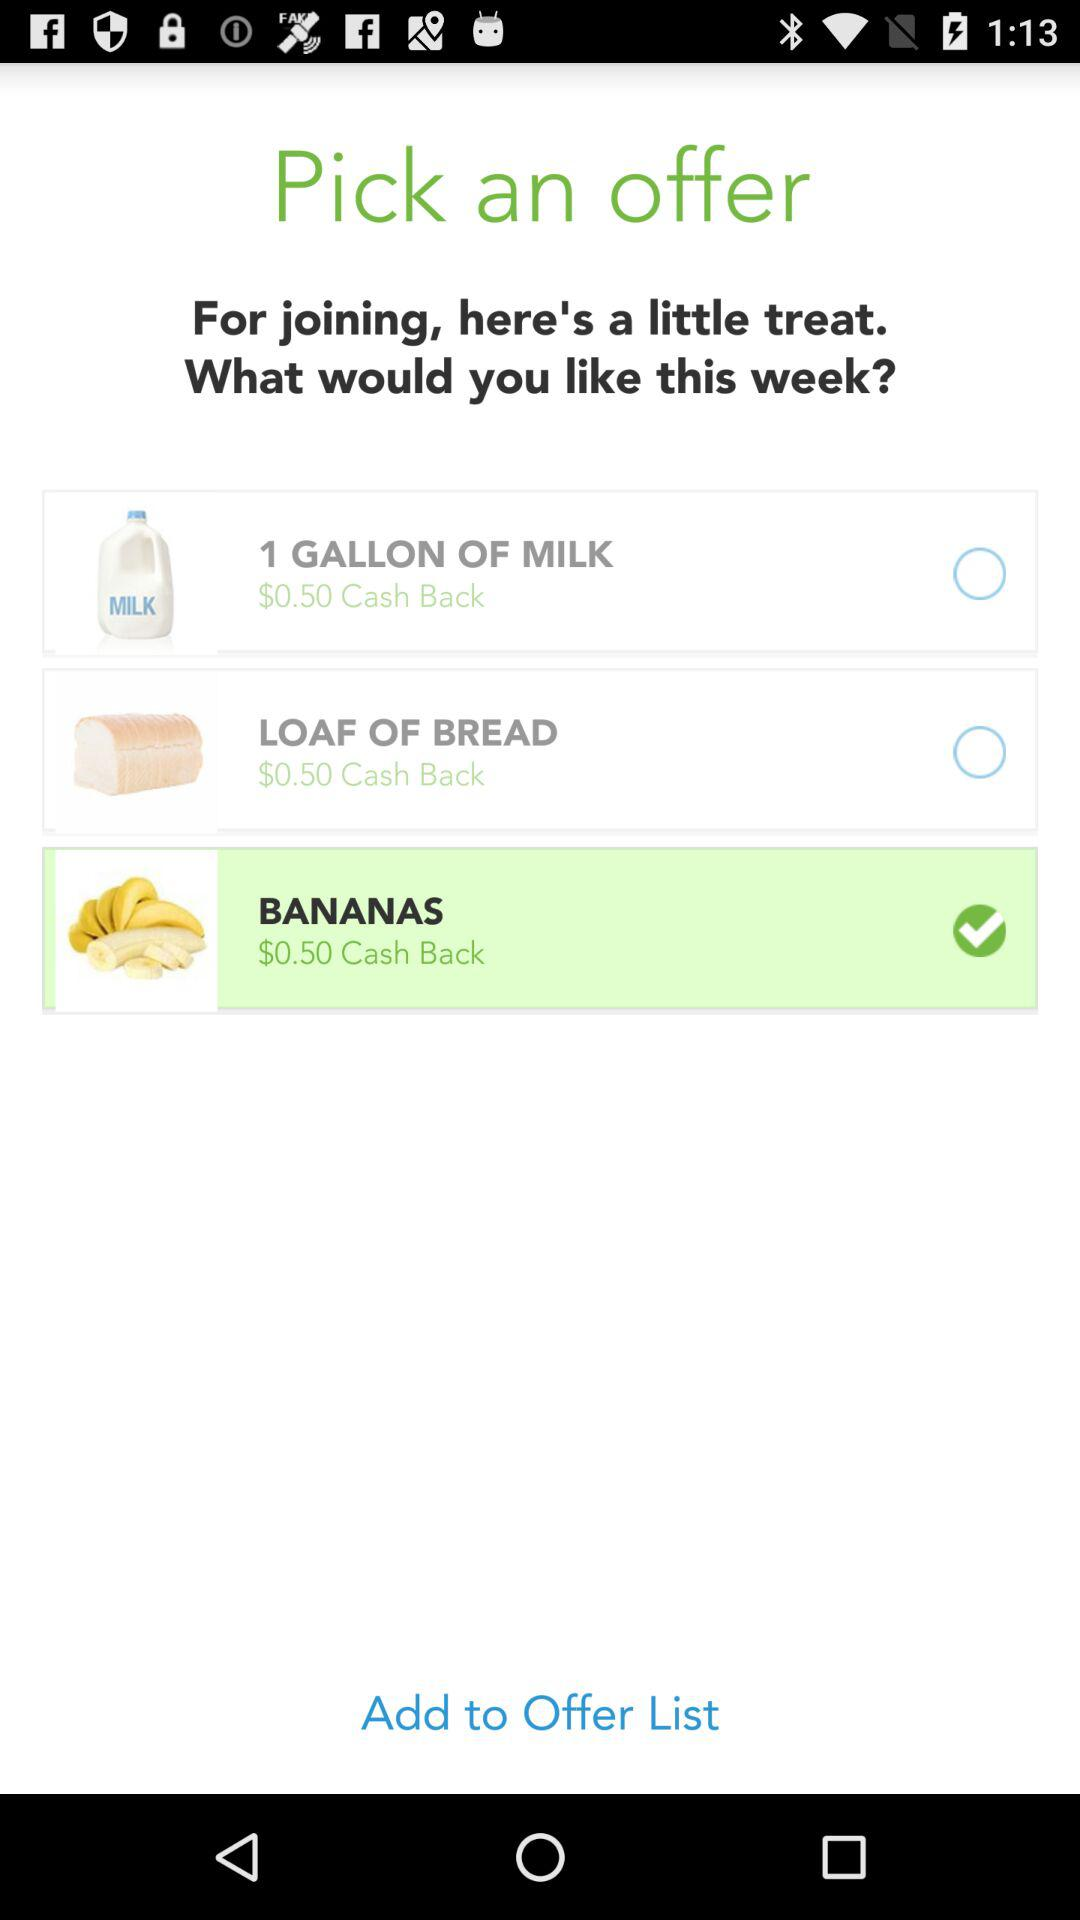How much cashback is applicable for bananas? The cashback for bananas is $0.50. 